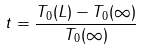<formula> <loc_0><loc_0><loc_500><loc_500>t = \frac { T _ { 0 } ( L ) - T _ { 0 } ( \infty ) } { T _ { 0 } ( \infty ) }</formula> 